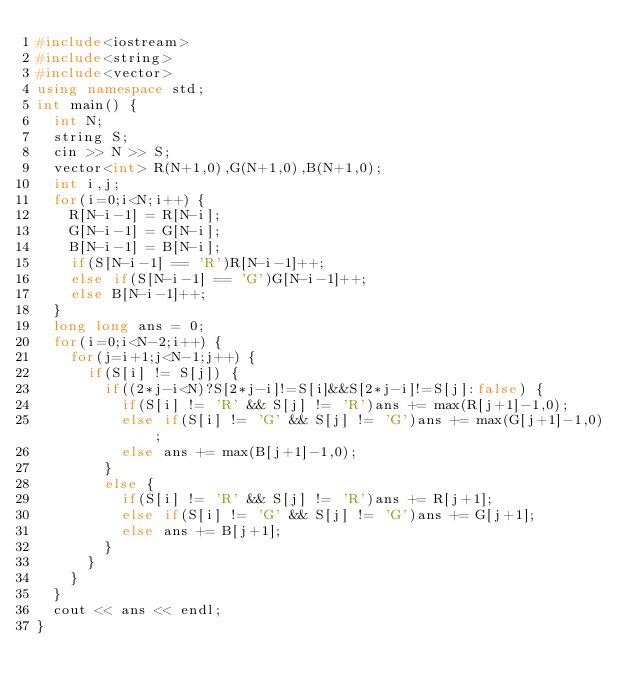Convert code to text. <code><loc_0><loc_0><loc_500><loc_500><_C++_>#include<iostream>
#include<string>
#include<vector>
using namespace std;
int main() {
	int N;
	string S;
	cin >> N >> S;
	vector<int> R(N+1,0),G(N+1,0),B(N+1,0);
	int i,j;
	for(i=0;i<N;i++) {
		R[N-i-1] = R[N-i];
		G[N-i-1] = G[N-i];
		B[N-i-1] = B[N-i];
		if(S[N-i-1] == 'R')R[N-i-1]++;
		else if(S[N-i-1] == 'G')G[N-i-1]++;
		else B[N-i-1]++;
	}
	long long ans = 0;
	for(i=0;i<N-2;i++) {
		for(j=i+1;j<N-1;j++) {
			if(S[i] != S[j]) {
				if((2*j-i<N)?S[2*j-i]!=S[i]&&S[2*j-i]!=S[j]:false) {
					if(S[i] != 'R' && S[j] != 'R')ans += max(R[j+1]-1,0);
					else if(S[i] != 'G' && S[j] != 'G')ans += max(G[j+1]-1,0);
					else ans += max(B[j+1]-1,0);
				}
				else {
					if(S[i] != 'R' && S[j] != 'R')ans += R[j+1];
					else if(S[i] != 'G' && S[j] != 'G')ans += G[j+1];
					else ans += B[j+1];
				}
			}
		}
	}
	cout << ans << endl;
}</code> 